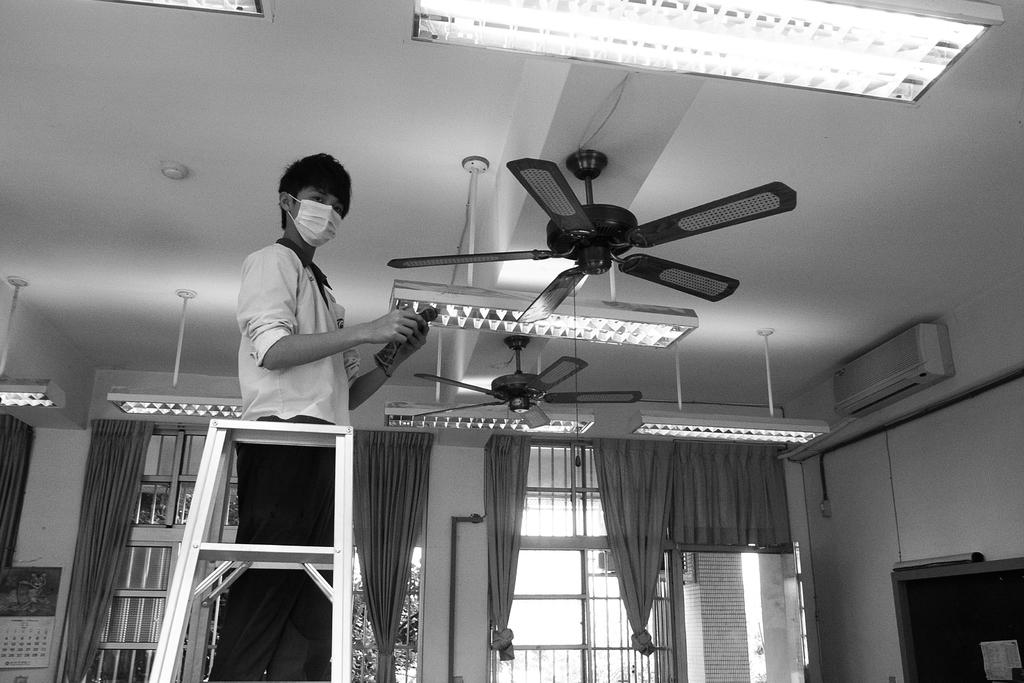What is the main subject of the image? There is a person in the image. What is the person doing in the image? The person is on a ladder. What is the person wearing in the image? The person is wearing clothes and a mask. What can be seen on the ceiling in the image? There are fans and lights on the ceiling. What is present on the wall in the image? There is an AC on the wall. What is covering the window in the image? There are curtains on the window. What is the name of the person on the ladder in the image? The image does not provide any information about the person's name. How heavy is the scale in the image? There is no scale present in the image. 